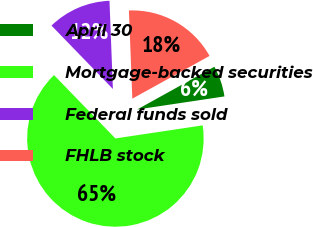<chart> <loc_0><loc_0><loc_500><loc_500><pie_chart><fcel>April 30<fcel>Mortgage-backed securities<fcel>Federal funds sold<fcel>FHLB stock<nl><fcel>5.68%<fcel>65.12%<fcel>11.63%<fcel>17.57%<nl></chart> 